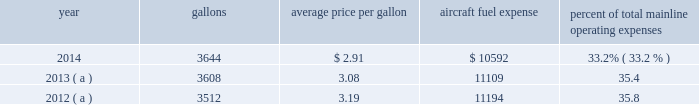Table of contents respect to the mainline american and the mainline us airways dispatchers , flight simulator engineers and flight crew training instructors , all of whom are now represented by the twu , a rival organization , the national association of airline professionals ( naap ) , filed single carrier applications seeking to represent those employees .
The nmb will have to determine that a single transportation system exists and will certify a post-merger representative of the combined employee groups before the process for negotiating new jcbas can begin .
The merger had no impact on the cbas that cover the employees of our wholly-owned subsidiary airlines which are not being merged ( envoy , piedmont and psa ) .
For those employees , the rla provides that cbas do not expire , but instead become amendable as of a stated date .
In 2014 , envoy pilots ratified a new 10 year collective bargaining agreement , piedmont pilots ratified a new 10 year collective bargaining agreement and piedmont flight attendants ratified a new five-year collective bargaining agreement .
With the exception of the passenger service employees who are now engaged in traditional rla negotiations that are expected to result in a jcba and the us airways flight simulator engineers and flight crew training instructors , other union-represented american mainline employees are covered by agreements that are not currently amendable .
Until those agreements become amendable , negotiations for jcbas will be conducted outside the traditional rla bargaining process described above , and , in the meantime , no self-help will be permissible .
The piedmont mechanics and stock clerks and the psa and piedmont dispatchers also have agreements that are now amendable and are engaged in traditional rla negotiations .
None of the unions representing our employees presently may lawfully engage in concerted refusals to work , such as strikes , slow-downs , sick-outs or other similar activity , against us .
Nonetheless , there is a risk that disgruntled employees , either with or without union involvement , could engage in one or more concerted refusals to work that could individually or collectively harm the operation of our airline and impair our financial performance .
For more discussion , see part i , item 1a .
Risk factors 2013 201cunion disputes , employee strikes and other labor-related disruptions may adversely affect our operations . 201d aircraft fuel our operations and financial results are significantly affected by the availability and price of jet fuel .
Based on our 2015 forecasted mainline and regional fuel consumption , we estimate that , as of december 31 , 2014 , a one cent per gallon increase in aviation fuel price would increase our 2015 annual fuel expense by $ 43 million .
The table shows annual aircraft fuel consumption and costs , including taxes , for our mainline operations for 2012 through 2014 ( gallons and aircraft fuel expense in millions ) .
Year gallons average price per gallon aircraft fuel expense percent of total mainline operating expenses .
( a ) represents 201ccombined 201d financial data , which includes the financial results of american and us airways group each on a standalone basis .
Total combined fuel expenses for our wholly-owned and third-party regional carriers operating under capacity purchase agreements of american and us airways group , each on a standalone basis , were $ 2.0 billion , $ 2.1 billion and $ 2.1 billion for the years ended december 31 , 2014 , 2013 and 2012 , respectively. .
What were total mainline operating expenses in 2013? 
Computations: (11109 / 35.4)
Answer: 313.81356. Table of contents respect to the mainline american and the mainline us airways dispatchers , flight simulator engineers and flight crew training instructors , all of whom are now represented by the twu , a rival organization , the national association of airline professionals ( naap ) , filed single carrier applications seeking to represent those employees .
The nmb will have to determine that a single transportation system exists and will certify a post-merger representative of the combined employee groups before the process for negotiating new jcbas can begin .
The merger had no impact on the cbas that cover the employees of our wholly-owned subsidiary airlines which are not being merged ( envoy , piedmont and psa ) .
For those employees , the rla provides that cbas do not expire , but instead become amendable as of a stated date .
In 2014 , envoy pilots ratified a new 10 year collective bargaining agreement , piedmont pilots ratified a new 10 year collective bargaining agreement and piedmont flight attendants ratified a new five-year collective bargaining agreement .
With the exception of the passenger service employees who are now engaged in traditional rla negotiations that are expected to result in a jcba and the us airways flight simulator engineers and flight crew training instructors , other union-represented american mainline employees are covered by agreements that are not currently amendable .
Until those agreements become amendable , negotiations for jcbas will be conducted outside the traditional rla bargaining process described above , and , in the meantime , no self-help will be permissible .
The piedmont mechanics and stock clerks and the psa and piedmont dispatchers also have agreements that are now amendable and are engaged in traditional rla negotiations .
None of the unions representing our employees presently may lawfully engage in concerted refusals to work , such as strikes , slow-downs , sick-outs or other similar activity , against us .
Nonetheless , there is a risk that disgruntled employees , either with or without union involvement , could engage in one or more concerted refusals to work that could individually or collectively harm the operation of our airline and impair our financial performance .
For more discussion , see part i , item 1a .
Risk factors 2013 201cunion disputes , employee strikes and other labor-related disruptions may adversely affect our operations . 201d aircraft fuel our operations and financial results are significantly affected by the availability and price of jet fuel .
Based on our 2015 forecasted mainline and regional fuel consumption , we estimate that , as of december 31 , 2014 , a one cent per gallon increase in aviation fuel price would increase our 2015 annual fuel expense by $ 43 million .
The table shows annual aircraft fuel consumption and costs , including taxes , for our mainline operations for 2012 through 2014 ( gallons and aircraft fuel expense in millions ) .
Year gallons average price per gallon aircraft fuel expense percent of total mainline operating expenses .
( a ) represents 201ccombined 201d financial data , which includes the financial results of american and us airways group each on a standalone basis .
Total combined fuel expenses for our wholly-owned and third-party regional carriers operating under capacity purchase agreements of american and us airways group , each on a standalone basis , were $ 2.0 billion , $ 2.1 billion and $ 2.1 billion for the years ended december 31 , 2014 , 2013 and 2012 , respectively. .
In 2015 what is the anticipated percentage increase in aircraft fuel expense from 2014? 
Rationale: the percent increase is the change divided by the original amount
Computations: (43 / 10592)
Answer: 0.00406. 